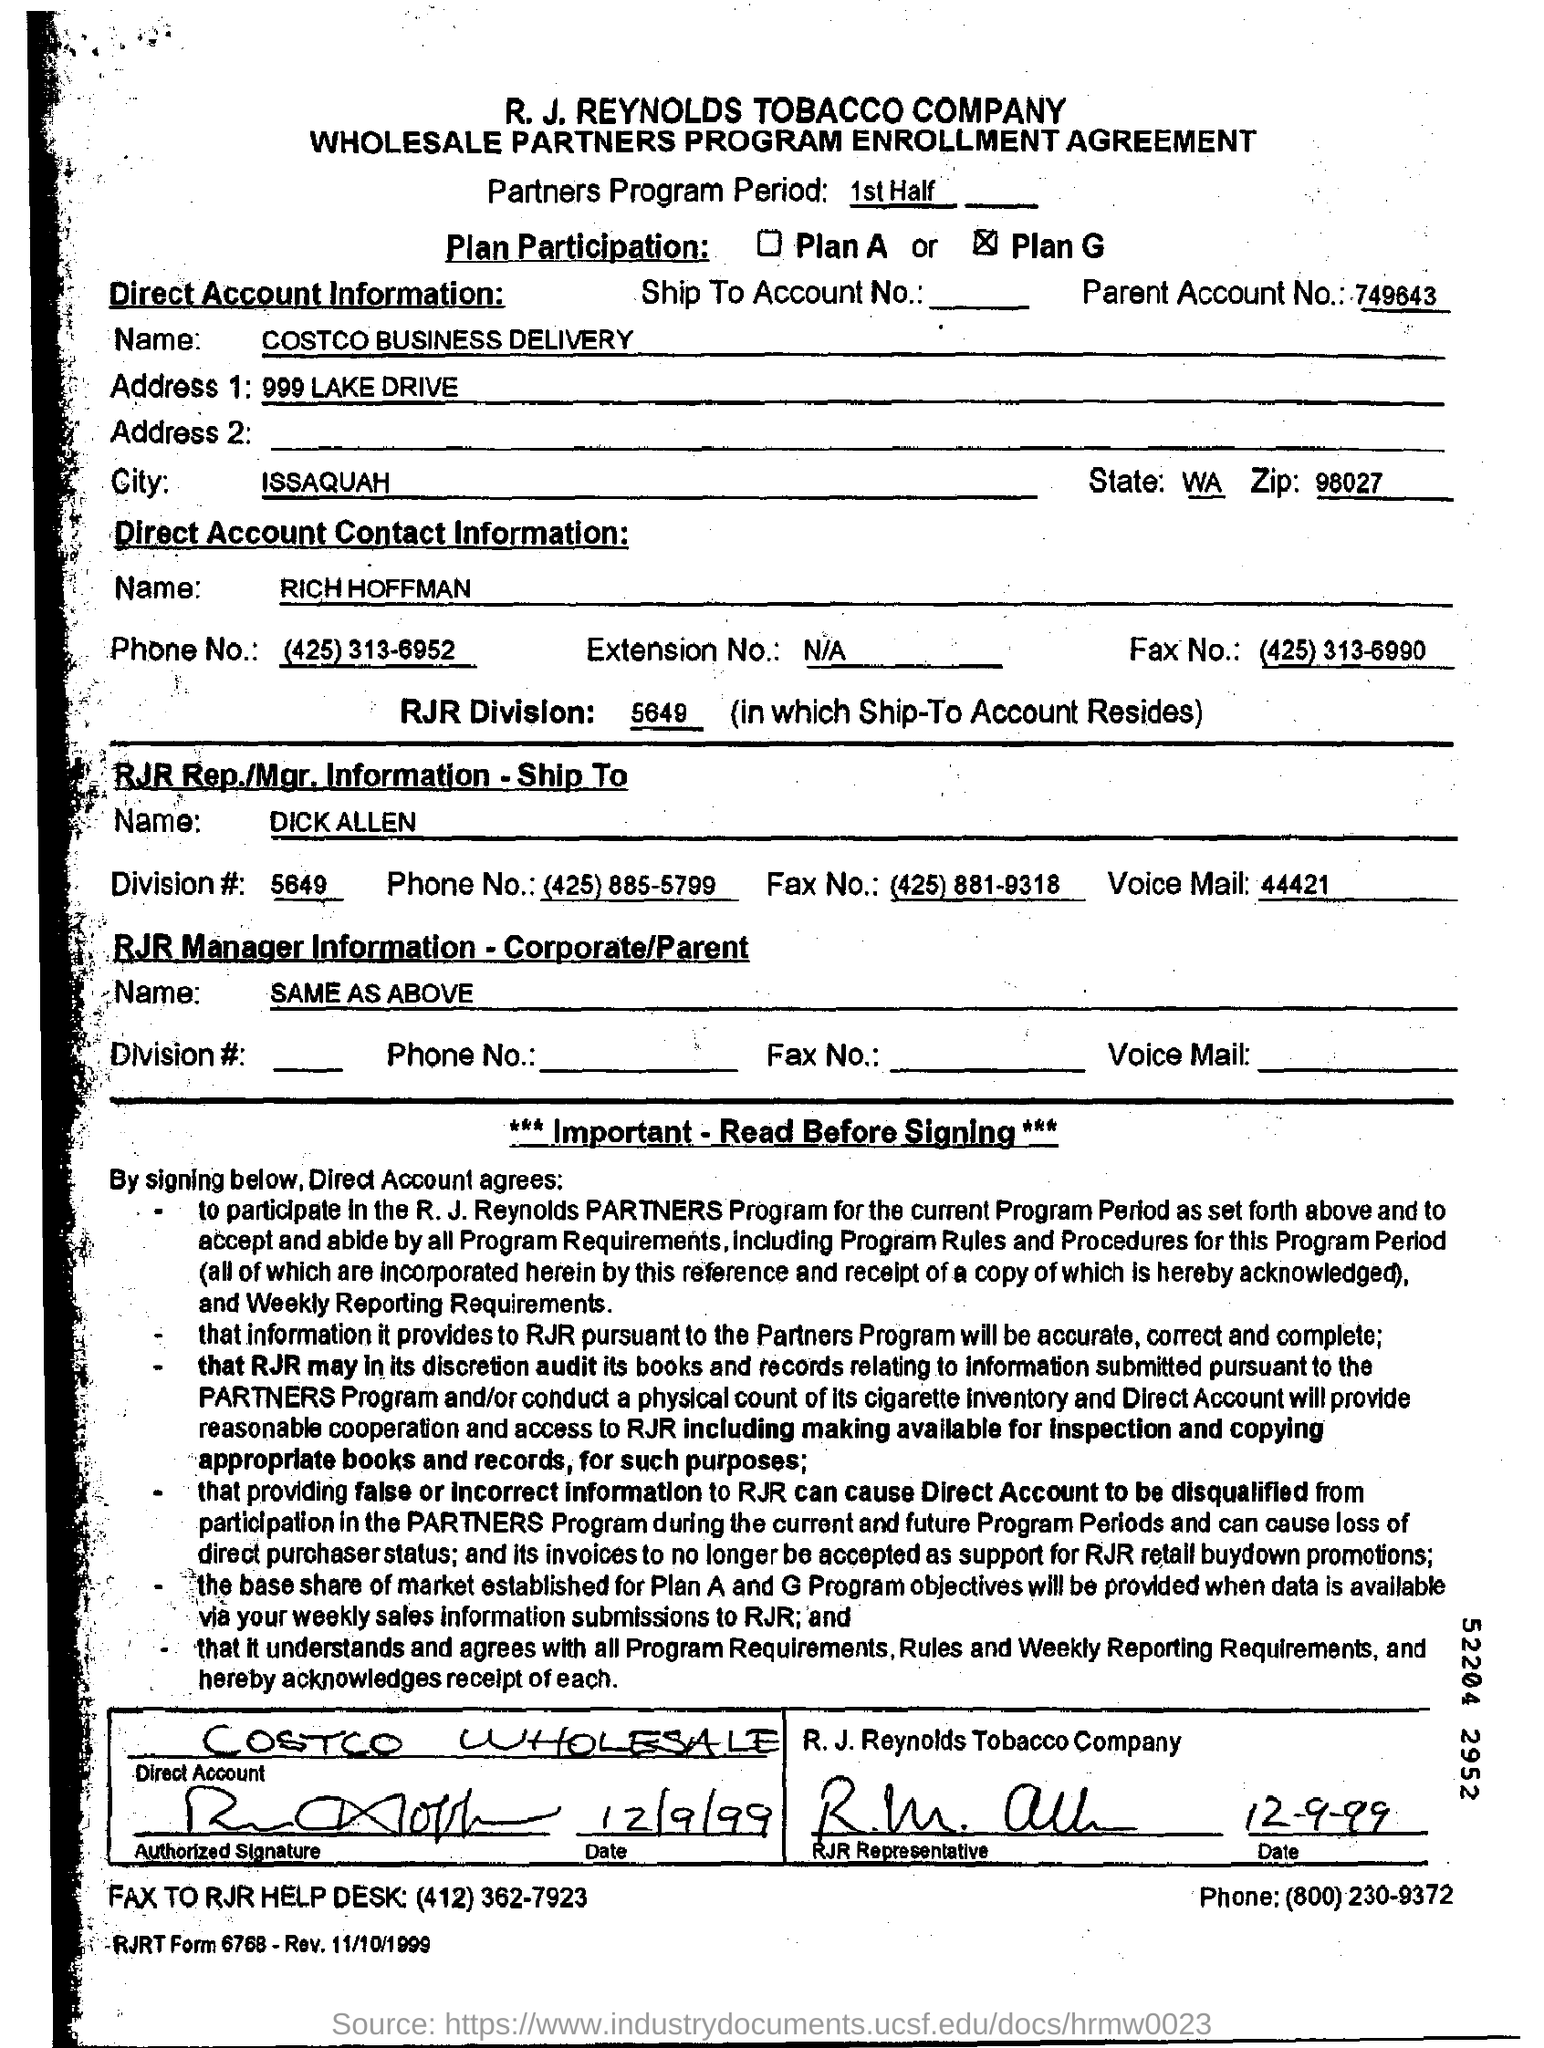What is the partners program period?
Your answer should be compact. 1st Half. What is the plan participation?
Provide a short and direct response. Plan G. What is the Parent Account No.?
Offer a terse response. 749643. What is the name under "Direct Account Information" ?
Keep it short and to the point. Costco business delivery. What is given in address 1 filed?
Offer a terse response. 999 LAKE DRIVE. What is the city  in "Direct Account Information"?
Provide a succinct answer. Issaquah. What is the Zip given in "Direct Account Information"?
Ensure brevity in your answer.  98027. 